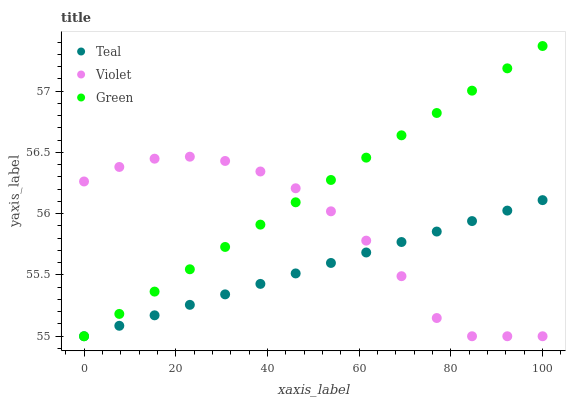Does Teal have the minimum area under the curve?
Answer yes or no. Yes. Does Green have the maximum area under the curve?
Answer yes or no. Yes. Does Violet have the minimum area under the curve?
Answer yes or no. No. Does Violet have the maximum area under the curve?
Answer yes or no. No. Is Teal the smoothest?
Answer yes or no. Yes. Is Violet the roughest?
Answer yes or no. Yes. Is Violet the smoothest?
Answer yes or no. No. Is Teal the roughest?
Answer yes or no. No. Does Green have the lowest value?
Answer yes or no. Yes. Does Green have the highest value?
Answer yes or no. Yes. Does Violet have the highest value?
Answer yes or no. No. Does Teal intersect Green?
Answer yes or no. Yes. Is Teal less than Green?
Answer yes or no. No. Is Teal greater than Green?
Answer yes or no. No. 